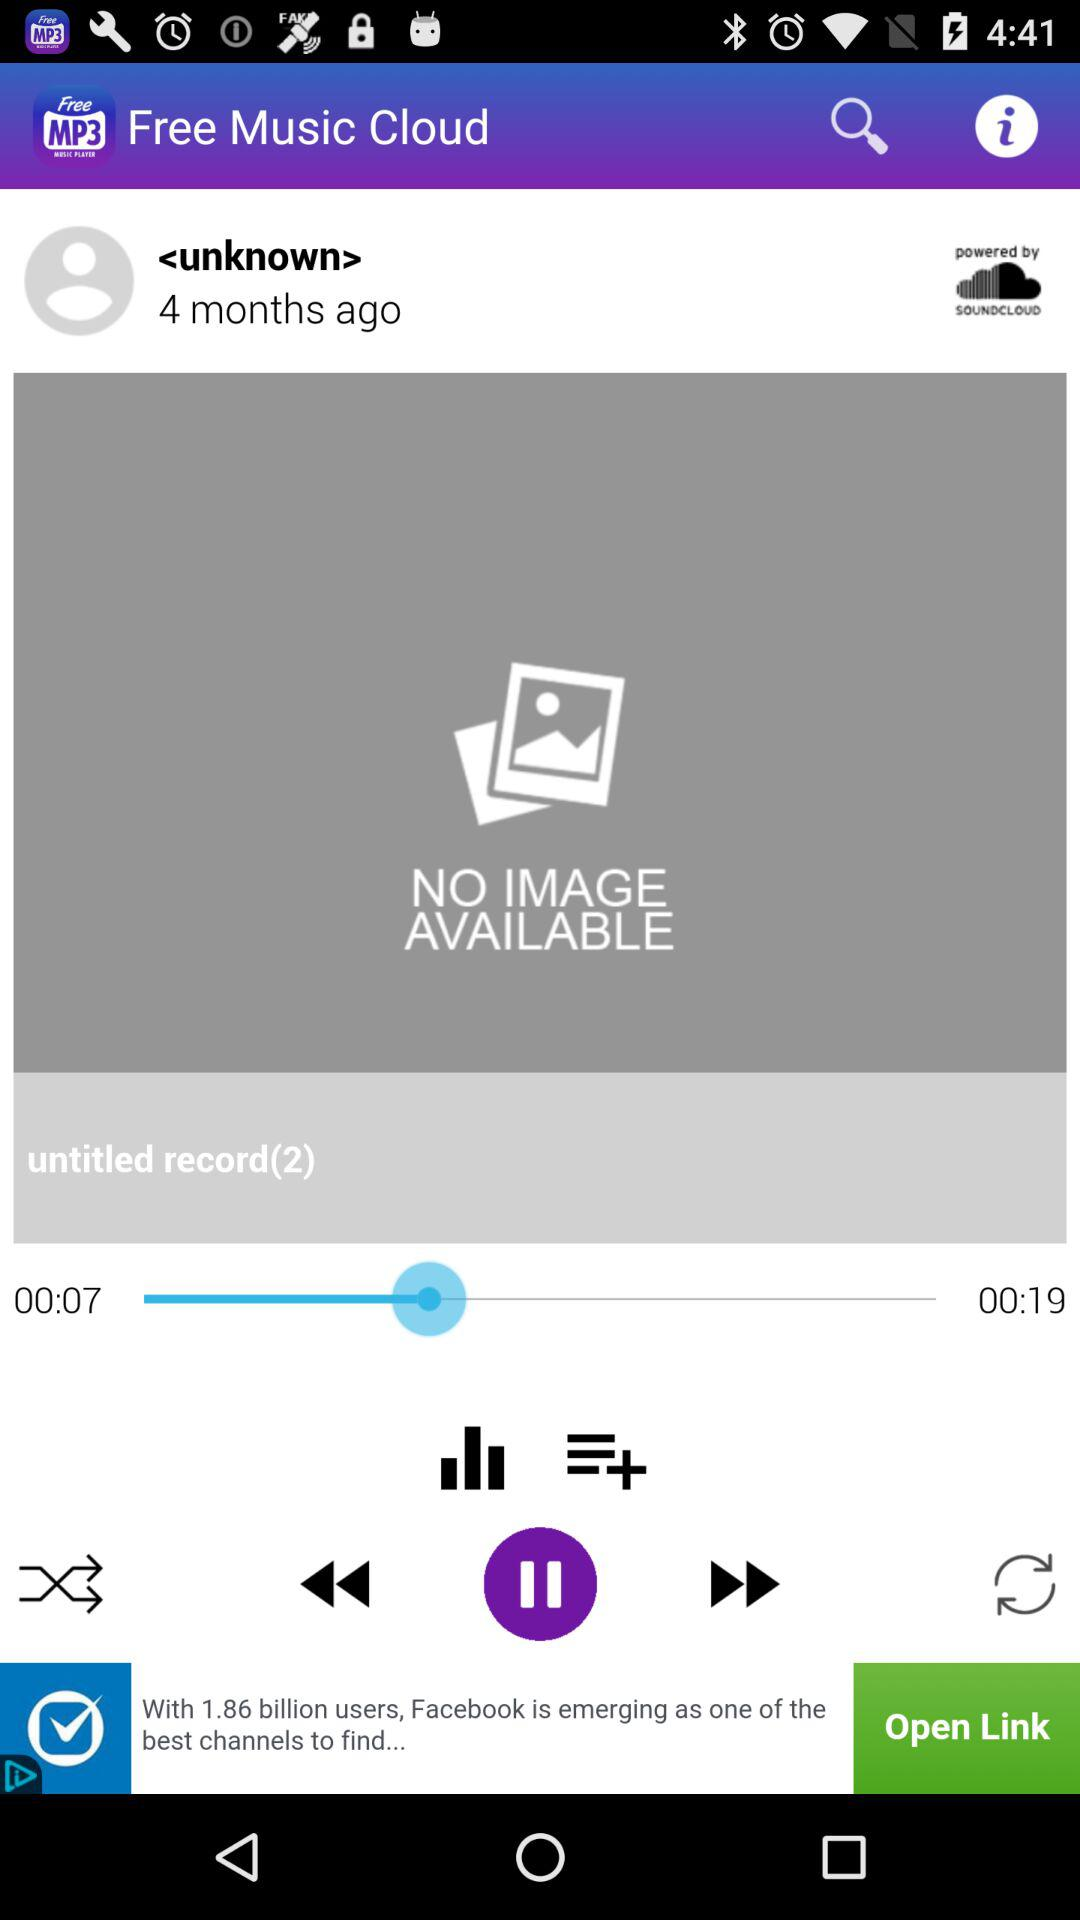Can you comment on the branding and sponsorship elements present in the image? The music player interfaces indicates a connection to SoundCloud, as suggested by the 'powered by SoundCloud' logo. Below, there is a banner advertisement suggesting the social media reach of Facebook, indicating that the app may utilize advertisement support or partnerships for revenue. 